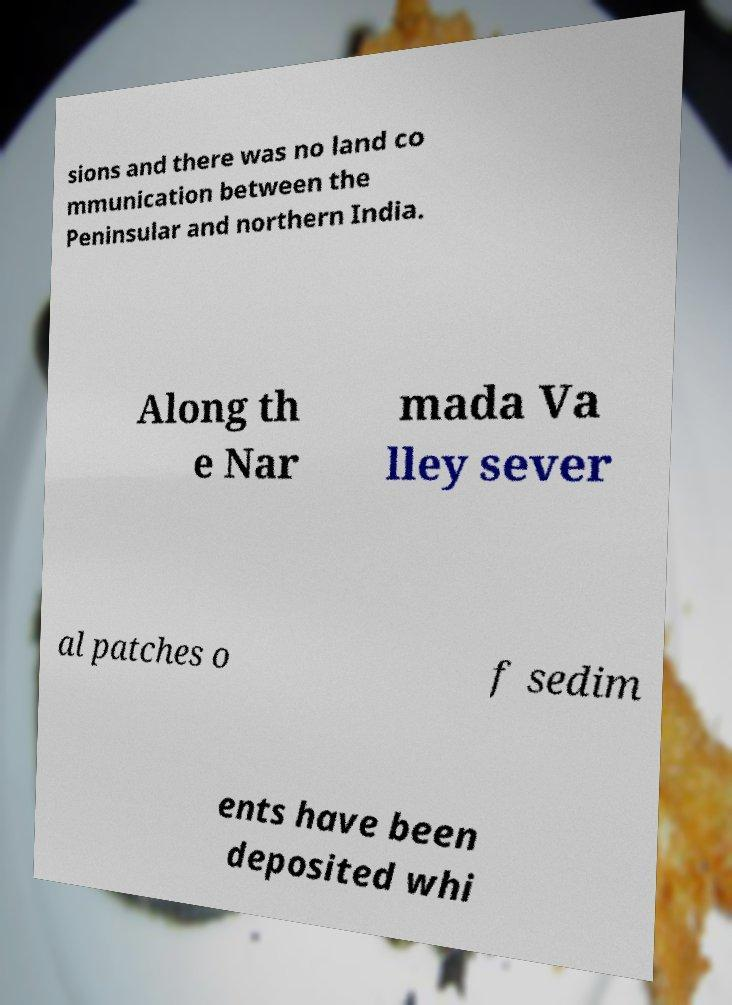What messages or text are displayed in this image? I need them in a readable, typed format. sions and there was no land co mmunication between the Peninsular and northern India. Along th e Nar mada Va lley sever al patches o f sedim ents have been deposited whi 